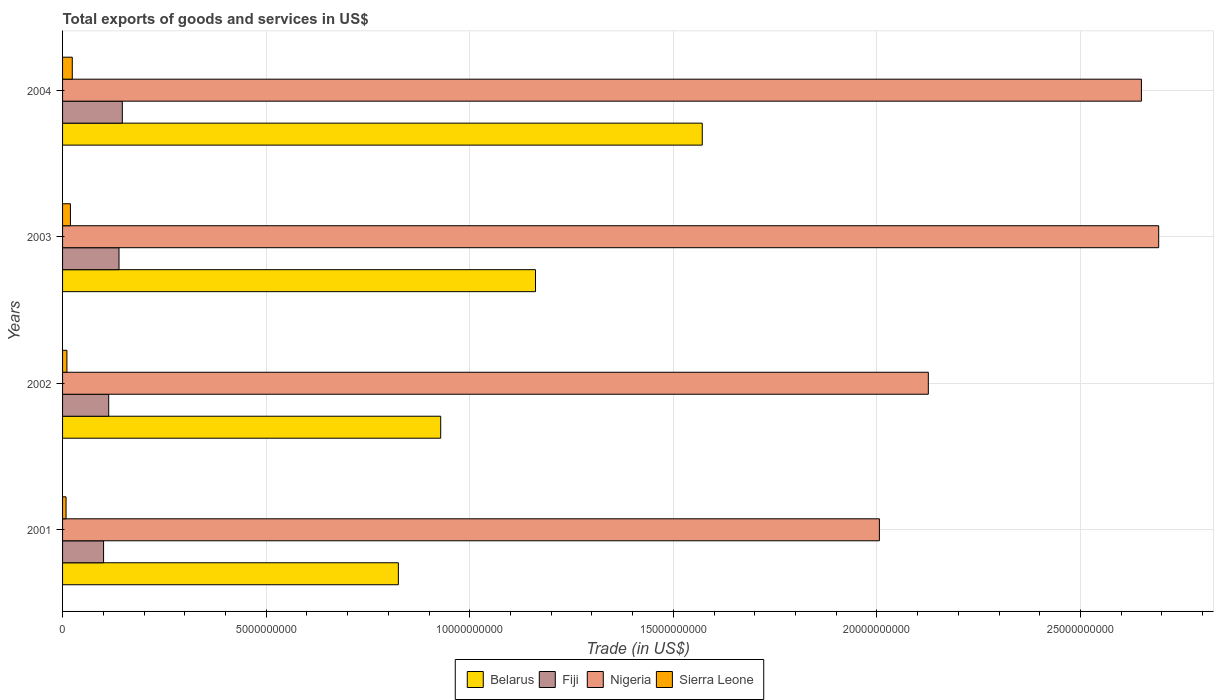How many different coloured bars are there?
Offer a very short reply. 4. How many groups of bars are there?
Provide a short and direct response. 4. In how many cases, is the number of bars for a given year not equal to the number of legend labels?
Your response must be concise. 0. What is the total exports of goods and services in Sierra Leone in 2003?
Keep it short and to the point. 1.93e+08. Across all years, what is the maximum total exports of goods and services in Sierra Leone?
Your response must be concise. 2.39e+08. Across all years, what is the minimum total exports of goods and services in Sierra Leone?
Provide a short and direct response. 8.55e+07. In which year was the total exports of goods and services in Sierra Leone maximum?
Provide a short and direct response. 2004. In which year was the total exports of goods and services in Fiji minimum?
Offer a very short reply. 2001. What is the total total exports of goods and services in Fiji in the graph?
Give a very brief answer. 4.99e+09. What is the difference between the total exports of goods and services in Sierra Leone in 2002 and that in 2004?
Your response must be concise. -1.31e+08. What is the difference between the total exports of goods and services in Sierra Leone in 2001 and the total exports of goods and services in Belarus in 2002?
Offer a terse response. -9.20e+09. What is the average total exports of goods and services in Sierra Leone per year?
Offer a very short reply. 1.56e+08. In the year 2003, what is the difference between the total exports of goods and services in Fiji and total exports of goods and services in Sierra Leone?
Offer a terse response. 1.19e+09. What is the ratio of the total exports of goods and services in Nigeria in 2001 to that in 2004?
Your response must be concise. 0.76. Is the difference between the total exports of goods and services in Fiji in 2002 and 2004 greater than the difference between the total exports of goods and services in Sierra Leone in 2002 and 2004?
Offer a very short reply. No. What is the difference between the highest and the second highest total exports of goods and services in Belarus?
Your response must be concise. 4.10e+09. What is the difference between the highest and the lowest total exports of goods and services in Fiji?
Your response must be concise. 4.61e+08. Is the sum of the total exports of goods and services in Nigeria in 2003 and 2004 greater than the maximum total exports of goods and services in Sierra Leone across all years?
Give a very brief answer. Yes. What does the 3rd bar from the top in 2003 represents?
Provide a short and direct response. Fiji. What does the 3rd bar from the bottom in 2001 represents?
Offer a terse response. Nigeria. Is it the case that in every year, the sum of the total exports of goods and services in Sierra Leone and total exports of goods and services in Fiji is greater than the total exports of goods and services in Nigeria?
Offer a very short reply. No. How many bars are there?
Your response must be concise. 16. Are all the bars in the graph horizontal?
Provide a succinct answer. Yes. Are the values on the major ticks of X-axis written in scientific E-notation?
Ensure brevity in your answer.  No. Does the graph contain any zero values?
Your answer should be compact. No. Does the graph contain grids?
Offer a very short reply. Yes. How many legend labels are there?
Make the answer very short. 4. What is the title of the graph?
Offer a terse response. Total exports of goods and services in US$. What is the label or title of the X-axis?
Make the answer very short. Trade (in US$). What is the Trade (in US$) of Belarus in 2001?
Keep it short and to the point. 8.25e+09. What is the Trade (in US$) of Fiji in 2001?
Offer a terse response. 1.01e+09. What is the Trade (in US$) in Nigeria in 2001?
Your answer should be very brief. 2.01e+1. What is the Trade (in US$) in Sierra Leone in 2001?
Provide a short and direct response. 8.55e+07. What is the Trade (in US$) in Belarus in 2002?
Make the answer very short. 9.29e+09. What is the Trade (in US$) of Fiji in 2002?
Your answer should be very brief. 1.13e+09. What is the Trade (in US$) in Nigeria in 2002?
Provide a succinct answer. 2.13e+1. What is the Trade (in US$) in Sierra Leone in 2002?
Make the answer very short. 1.07e+08. What is the Trade (in US$) of Belarus in 2003?
Provide a succinct answer. 1.16e+1. What is the Trade (in US$) of Fiji in 2003?
Provide a short and direct response. 1.39e+09. What is the Trade (in US$) in Nigeria in 2003?
Offer a terse response. 2.69e+1. What is the Trade (in US$) of Sierra Leone in 2003?
Provide a succinct answer. 1.93e+08. What is the Trade (in US$) of Belarus in 2004?
Ensure brevity in your answer.  1.57e+1. What is the Trade (in US$) of Fiji in 2004?
Keep it short and to the point. 1.47e+09. What is the Trade (in US$) in Nigeria in 2004?
Keep it short and to the point. 2.65e+1. What is the Trade (in US$) in Sierra Leone in 2004?
Ensure brevity in your answer.  2.39e+08. Across all years, what is the maximum Trade (in US$) of Belarus?
Your response must be concise. 1.57e+1. Across all years, what is the maximum Trade (in US$) of Fiji?
Offer a terse response. 1.47e+09. Across all years, what is the maximum Trade (in US$) in Nigeria?
Keep it short and to the point. 2.69e+1. Across all years, what is the maximum Trade (in US$) of Sierra Leone?
Keep it short and to the point. 2.39e+08. Across all years, what is the minimum Trade (in US$) in Belarus?
Ensure brevity in your answer.  8.25e+09. Across all years, what is the minimum Trade (in US$) of Fiji?
Keep it short and to the point. 1.01e+09. Across all years, what is the minimum Trade (in US$) in Nigeria?
Provide a succinct answer. 2.01e+1. Across all years, what is the minimum Trade (in US$) of Sierra Leone?
Keep it short and to the point. 8.55e+07. What is the total Trade (in US$) of Belarus in the graph?
Your answer should be compact. 4.49e+1. What is the total Trade (in US$) in Fiji in the graph?
Offer a very short reply. 4.99e+09. What is the total Trade (in US$) in Nigeria in the graph?
Ensure brevity in your answer.  9.47e+1. What is the total Trade (in US$) of Sierra Leone in the graph?
Make the answer very short. 6.24e+08. What is the difference between the Trade (in US$) in Belarus in 2001 and that in 2002?
Offer a very short reply. -1.04e+09. What is the difference between the Trade (in US$) of Fiji in 2001 and that in 2002?
Offer a very short reply. -1.26e+08. What is the difference between the Trade (in US$) in Nigeria in 2001 and that in 2002?
Give a very brief answer. -1.20e+09. What is the difference between the Trade (in US$) in Sierra Leone in 2001 and that in 2002?
Your answer should be very brief. -2.17e+07. What is the difference between the Trade (in US$) in Belarus in 2001 and that in 2003?
Provide a short and direct response. -3.37e+09. What is the difference between the Trade (in US$) in Fiji in 2001 and that in 2003?
Make the answer very short. -3.79e+08. What is the difference between the Trade (in US$) of Nigeria in 2001 and that in 2003?
Provide a short and direct response. -6.86e+09. What is the difference between the Trade (in US$) in Sierra Leone in 2001 and that in 2003?
Ensure brevity in your answer.  -1.07e+08. What is the difference between the Trade (in US$) of Belarus in 2001 and that in 2004?
Provide a short and direct response. -7.46e+09. What is the difference between the Trade (in US$) of Fiji in 2001 and that in 2004?
Your answer should be compact. -4.61e+08. What is the difference between the Trade (in US$) in Nigeria in 2001 and that in 2004?
Keep it short and to the point. -6.43e+09. What is the difference between the Trade (in US$) in Sierra Leone in 2001 and that in 2004?
Your answer should be very brief. -1.53e+08. What is the difference between the Trade (in US$) of Belarus in 2002 and that in 2003?
Give a very brief answer. -2.33e+09. What is the difference between the Trade (in US$) in Fiji in 2002 and that in 2003?
Provide a succinct answer. -2.54e+08. What is the difference between the Trade (in US$) in Nigeria in 2002 and that in 2003?
Provide a short and direct response. -5.66e+09. What is the difference between the Trade (in US$) in Sierra Leone in 2002 and that in 2003?
Provide a short and direct response. -8.58e+07. What is the difference between the Trade (in US$) in Belarus in 2002 and that in 2004?
Offer a terse response. -6.42e+09. What is the difference between the Trade (in US$) of Fiji in 2002 and that in 2004?
Your answer should be very brief. -3.35e+08. What is the difference between the Trade (in US$) in Nigeria in 2002 and that in 2004?
Offer a terse response. -5.23e+09. What is the difference between the Trade (in US$) in Sierra Leone in 2002 and that in 2004?
Your answer should be compact. -1.31e+08. What is the difference between the Trade (in US$) of Belarus in 2003 and that in 2004?
Keep it short and to the point. -4.10e+09. What is the difference between the Trade (in US$) of Fiji in 2003 and that in 2004?
Provide a succinct answer. -8.13e+07. What is the difference between the Trade (in US$) in Nigeria in 2003 and that in 2004?
Provide a succinct answer. 4.24e+08. What is the difference between the Trade (in US$) of Sierra Leone in 2003 and that in 2004?
Make the answer very short. -4.57e+07. What is the difference between the Trade (in US$) in Belarus in 2001 and the Trade (in US$) in Fiji in 2002?
Provide a short and direct response. 7.11e+09. What is the difference between the Trade (in US$) of Belarus in 2001 and the Trade (in US$) of Nigeria in 2002?
Your answer should be compact. -1.30e+1. What is the difference between the Trade (in US$) of Belarus in 2001 and the Trade (in US$) of Sierra Leone in 2002?
Provide a short and direct response. 8.14e+09. What is the difference between the Trade (in US$) of Fiji in 2001 and the Trade (in US$) of Nigeria in 2002?
Ensure brevity in your answer.  -2.03e+1. What is the difference between the Trade (in US$) of Fiji in 2001 and the Trade (in US$) of Sierra Leone in 2002?
Keep it short and to the point. 9.00e+08. What is the difference between the Trade (in US$) of Nigeria in 2001 and the Trade (in US$) of Sierra Leone in 2002?
Ensure brevity in your answer.  2.00e+1. What is the difference between the Trade (in US$) in Belarus in 2001 and the Trade (in US$) in Fiji in 2003?
Offer a very short reply. 6.86e+09. What is the difference between the Trade (in US$) in Belarus in 2001 and the Trade (in US$) in Nigeria in 2003?
Keep it short and to the point. -1.87e+1. What is the difference between the Trade (in US$) of Belarus in 2001 and the Trade (in US$) of Sierra Leone in 2003?
Offer a terse response. 8.05e+09. What is the difference between the Trade (in US$) of Fiji in 2001 and the Trade (in US$) of Nigeria in 2003?
Give a very brief answer. -2.59e+1. What is the difference between the Trade (in US$) in Fiji in 2001 and the Trade (in US$) in Sierra Leone in 2003?
Provide a short and direct response. 8.14e+08. What is the difference between the Trade (in US$) in Nigeria in 2001 and the Trade (in US$) in Sierra Leone in 2003?
Your response must be concise. 1.99e+1. What is the difference between the Trade (in US$) in Belarus in 2001 and the Trade (in US$) in Fiji in 2004?
Your answer should be compact. 6.78e+09. What is the difference between the Trade (in US$) of Belarus in 2001 and the Trade (in US$) of Nigeria in 2004?
Your answer should be very brief. -1.82e+1. What is the difference between the Trade (in US$) in Belarus in 2001 and the Trade (in US$) in Sierra Leone in 2004?
Your response must be concise. 8.01e+09. What is the difference between the Trade (in US$) in Fiji in 2001 and the Trade (in US$) in Nigeria in 2004?
Make the answer very short. -2.55e+1. What is the difference between the Trade (in US$) in Fiji in 2001 and the Trade (in US$) in Sierra Leone in 2004?
Offer a terse response. 7.69e+08. What is the difference between the Trade (in US$) of Nigeria in 2001 and the Trade (in US$) of Sierra Leone in 2004?
Give a very brief answer. 1.98e+1. What is the difference between the Trade (in US$) of Belarus in 2002 and the Trade (in US$) of Fiji in 2003?
Offer a very short reply. 7.90e+09. What is the difference between the Trade (in US$) in Belarus in 2002 and the Trade (in US$) in Nigeria in 2003?
Ensure brevity in your answer.  -1.76e+1. What is the difference between the Trade (in US$) of Belarus in 2002 and the Trade (in US$) of Sierra Leone in 2003?
Offer a terse response. 9.09e+09. What is the difference between the Trade (in US$) of Fiji in 2002 and the Trade (in US$) of Nigeria in 2003?
Keep it short and to the point. -2.58e+1. What is the difference between the Trade (in US$) of Fiji in 2002 and the Trade (in US$) of Sierra Leone in 2003?
Make the answer very short. 9.40e+08. What is the difference between the Trade (in US$) in Nigeria in 2002 and the Trade (in US$) in Sierra Leone in 2003?
Your answer should be compact. 2.11e+1. What is the difference between the Trade (in US$) of Belarus in 2002 and the Trade (in US$) of Fiji in 2004?
Ensure brevity in your answer.  7.82e+09. What is the difference between the Trade (in US$) in Belarus in 2002 and the Trade (in US$) in Nigeria in 2004?
Provide a short and direct response. -1.72e+1. What is the difference between the Trade (in US$) of Belarus in 2002 and the Trade (in US$) of Sierra Leone in 2004?
Provide a short and direct response. 9.05e+09. What is the difference between the Trade (in US$) of Fiji in 2002 and the Trade (in US$) of Nigeria in 2004?
Provide a succinct answer. -2.54e+1. What is the difference between the Trade (in US$) of Fiji in 2002 and the Trade (in US$) of Sierra Leone in 2004?
Your response must be concise. 8.94e+08. What is the difference between the Trade (in US$) of Nigeria in 2002 and the Trade (in US$) of Sierra Leone in 2004?
Your response must be concise. 2.10e+1. What is the difference between the Trade (in US$) of Belarus in 2003 and the Trade (in US$) of Fiji in 2004?
Give a very brief answer. 1.01e+1. What is the difference between the Trade (in US$) in Belarus in 2003 and the Trade (in US$) in Nigeria in 2004?
Your response must be concise. -1.49e+1. What is the difference between the Trade (in US$) in Belarus in 2003 and the Trade (in US$) in Sierra Leone in 2004?
Provide a succinct answer. 1.14e+1. What is the difference between the Trade (in US$) in Fiji in 2003 and the Trade (in US$) in Nigeria in 2004?
Make the answer very short. -2.51e+1. What is the difference between the Trade (in US$) of Fiji in 2003 and the Trade (in US$) of Sierra Leone in 2004?
Your answer should be compact. 1.15e+09. What is the difference between the Trade (in US$) in Nigeria in 2003 and the Trade (in US$) in Sierra Leone in 2004?
Offer a terse response. 2.67e+1. What is the average Trade (in US$) of Belarus per year?
Make the answer very short. 1.12e+1. What is the average Trade (in US$) of Fiji per year?
Offer a terse response. 1.25e+09. What is the average Trade (in US$) in Nigeria per year?
Give a very brief answer. 2.37e+1. What is the average Trade (in US$) of Sierra Leone per year?
Your answer should be very brief. 1.56e+08. In the year 2001, what is the difference between the Trade (in US$) of Belarus and Trade (in US$) of Fiji?
Keep it short and to the point. 7.24e+09. In the year 2001, what is the difference between the Trade (in US$) in Belarus and Trade (in US$) in Nigeria?
Provide a short and direct response. -1.18e+1. In the year 2001, what is the difference between the Trade (in US$) of Belarus and Trade (in US$) of Sierra Leone?
Make the answer very short. 8.16e+09. In the year 2001, what is the difference between the Trade (in US$) of Fiji and Trade (in US$) of Nigeria?
Your answer should be very brief. -1.91e+1. In the year 2001, what is the difference between the Trade (in US$) of Fiji and Trade (in US$) of Sierra Leone?
Give a very brief answer. 9.22e+08. In the year 2001, what is the difference between the Trade (in US$) in Nigeria and Trade (in US$) in Sierra Leone?
Offer a very short reply. 2.00e+1. In the year 2002, what is the difference between the Trade (in US$) of Belarus and Trade (in US$) of Fiji?
Keep it short and to the point. 8.15e+09. In the year 2002, what is the difference between the Trade (in US$) in Belarus and Trade (in US$) in Nigeria?
Give a very brief answer. -1.20e+1. In the year 2002, what is the difference between the Trade (in US$) in Belarus and Trade (in US$) in Sierra Leone?
Give a very brief answer. 9.18e+09. In the year 2002, what is the difference between the Trade (in US$) in Fiji and Trade (in US$) in Nigeria?
Make the answer very short. -2.01e+1. In the year 2002, what is the difference between the Trade (in US$) of Fiji and Trade (in US$) of Sierra Leone?
Your answer should be compact. 1.03e+09. In the year 2002, what is the difference between the Trade (in US$) of Nigeria and Trade (in US$) of Sierra Leone?
Your answer should be compact. 2.12e+1. In the year 2003, what is the difference between the Trade (in US$) of Belarus and Trade (in US$) of Fiji?
Provide a short and direct response. 1.02e+1. In the year 2003, what is the difference between the Trade (in US$) in Belarus and Trade (in US$) in Nigeria?
Your response must be concise. -1.53e+1. In the year 2003, what is the difference between the Trade (in US$) in Belarus and Trade (in US$) in Sierra Leone?
Provide a succinct answer. 1.14e+1. In the year 2003, what is the difference between the Trade (in US$) in Fiji and Trade (in US$) in Nigeria?
Your response must be concise. -2.55e+1. In the year 2003, what is the difference between the Trade (in US$) of Fiji and Trade (in US$) of Sierra Leone?
Keep it short and to the point. 1.19e+09. In the year 2003, what is the difference between the Trade (in US$) of Nigeria and Trade (in US$) of Sierra Leone?
Make the answer very short. 2.67e+1. In the year 2004, what is the difference between the Trade (in US$) in Belarus and Trade (in US$) in Fiji?
Make the answer very short. 1.42e+1. In the year 2004, what is the difference between the Trade (in US$) of Belarus and Trade (in US$) of Nigeria?
Offer a terse response. -1.08e+1. In the year 2004, what is the difference between the Trade (in US$) in Belarus and Trade (in US$) in Sierra Leone?
Your response must be concise. 1.55e+1. In the year 2004, what is the difference between the Trade (in US$) in Fiji and Trade (in US$) in Nigeria?
Provide a short and direct response. -2.50e+1. In the year 2004, what is the difference between the Trade (in US$) in Fiji and Trade (in US$) in Sierra Leone?
Provide a succinct answer. 1.23e+09. In the year 2004, what is the difference between the Trade (in US$) in Nigeria and Trade (in US$) in Sierra Leone?
Keep it short and to the point. 2.63e+1. What is the ratio of the Trade (in US$) in Belarus in 2001 to that in 2002?
Provide a short and direct response. 0.89. What is the ratio of the Trade (in US$) in Fiji in 2001 to that in 2002?
Ensure brevity in your answer.  0.89. What is the ratio of the Trade (in US$) of Nigeria in 2001 to that in 2002?
Keep it short and to the point. 0.94. What is the ratio of the Trade (in US$) in Sierra Leone in 2001 to that in 2002?
Your answer should be very brief. 0.8. What is the ratio of the Trade (in US$) in Belarus in 2001 to that in 2003?
Your answer should be compact. 0.71. What is the ratio of the Trade (in US$) in Fiji in 2001 to that in 2003?
Make the answer very short. 0.73. What is the ratio of the Trade (in US$) in Nigeria in 2001 to that in 2003?
Your answer should be very brief. 0.75. What is the ratio of the Trade (in US$) of Sierra Leone in 2001 to that in 2003?
Offer a very short reply. 0.44. What is the ratio of the Trade (in US$) of Belarus in 2001 to that in 2004?
Offer a terse response. 0.52. What is the ratio of the Trade (in US$) of Fiji in 2001 to that in 2004?
Your answer should be compact. 0.69. What is the ratio of the Trade (in US$) in Nigeria in 2001 to that in 2004?
Give a very brief answer. 0.76. What is the ratio of the Trade (in US$) of Sierra Leone in 2001 to that in 2004?
Provide a succinct answer. 0.36. What is the ratio of the Trade (in US$) in Belarus in 2002 to that in 2003?
Your answer should be very brief. 0.8. What is the ratio of the Trade (in US$) of Fiji in 2002 to that in 2003?
Provide a succinct answer. 0.82. What is the ratio of the Trade (in US$) of Nigeria in 2002 to that in 2003?
Make the answer very short. 0.79. What is the ratio of the Trade (in US$) of Sierra Leone in 2002 to that in 2003?
Your response must be concise. 0.56. What is the ratio of the Trade (in US$) of Belarus in 2002 to that in 2004?
Keep it short and to the point. 0.59. What is the ratio of the Trade (in US$) in Fiji in 2002 to that in 2004?
Ensure brevity in your answer.  0.77. What is the ratio of the Trade (in US$) of Nigeria in 2002 to that in 2004?
Offer a terse response. 0.8. What is the ratio of the Trade (in US$) in Sierra Leone in 2002 to that in 2004?
Your response must be concise. 0.45. What is the ratio of the Trade (in US$) in Belarus in 2003 to that in 2004?
Provide a succinct answer. 0.74. What is the ratio of the Trade (in US$) of Fiji in 2003 to that in 2004?
Your answer should be compact. 0.94. What is the ratio of the Trade (in US$) in Nigeria in 2003 to that in 2004?
Provide a succinct answer. 1.02. What is the ratio of the Trade (in US$) in Sierra Leone in 2003 to that in 2004?
Your answer should be compact. 0.81. What is the difference between the highest and the second highest Trade (in US$) of Belarus?
Your response must be concise. 4.10e+09. What is the difference between the highest and the second highest Trade (in US$) of Fiji?
Provide a succinct answer. 8.13e+07. What is the difference between the highest and the second highest Trade (in US$) of Nigeria?
Provide a short and direct response. 4.24e+08. What is the difference between the highest and the second highest Trade (in US$) of Sierra Leone?
Your answer should be very brief. 4.57e+07. What is the difference between the highest and the lowest Trade (in US$) of Belarus?
Provide a short and direct response. 7.46e+09. What is the difference between the highest and the lowest Trade (in US$) of Fiji?
Your answer should be compact. 4.61e+08. What is the difference between the highest and the lowest Trade (in US$) of Nigeria?
Your answer should be very brief. 6.86e+09. What is the difference between the highest and the lowest Trade (in US$) in Sierra Leone?
Your answer should be very brief. 1.53e+08. 